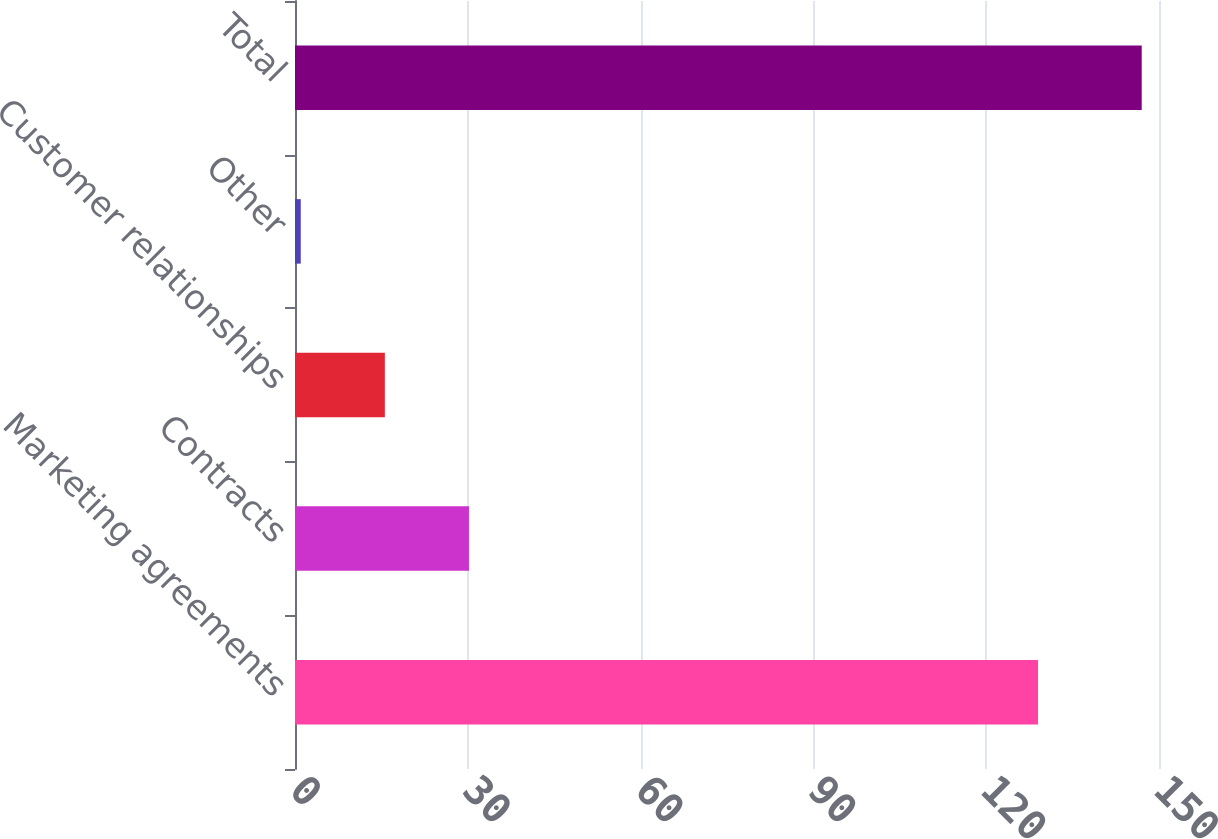<chart> <loc_0><loc_0><loc_500><loc_500><bar_chart><fcel>Marketing agreements<fcel>Contracts<fcel>Customer relationships<fcel>Other<fcel>Total<nl><fcel>129<fcel>30.2<fcel>15.6<fcel>1<fcel>147<nl></chart> 